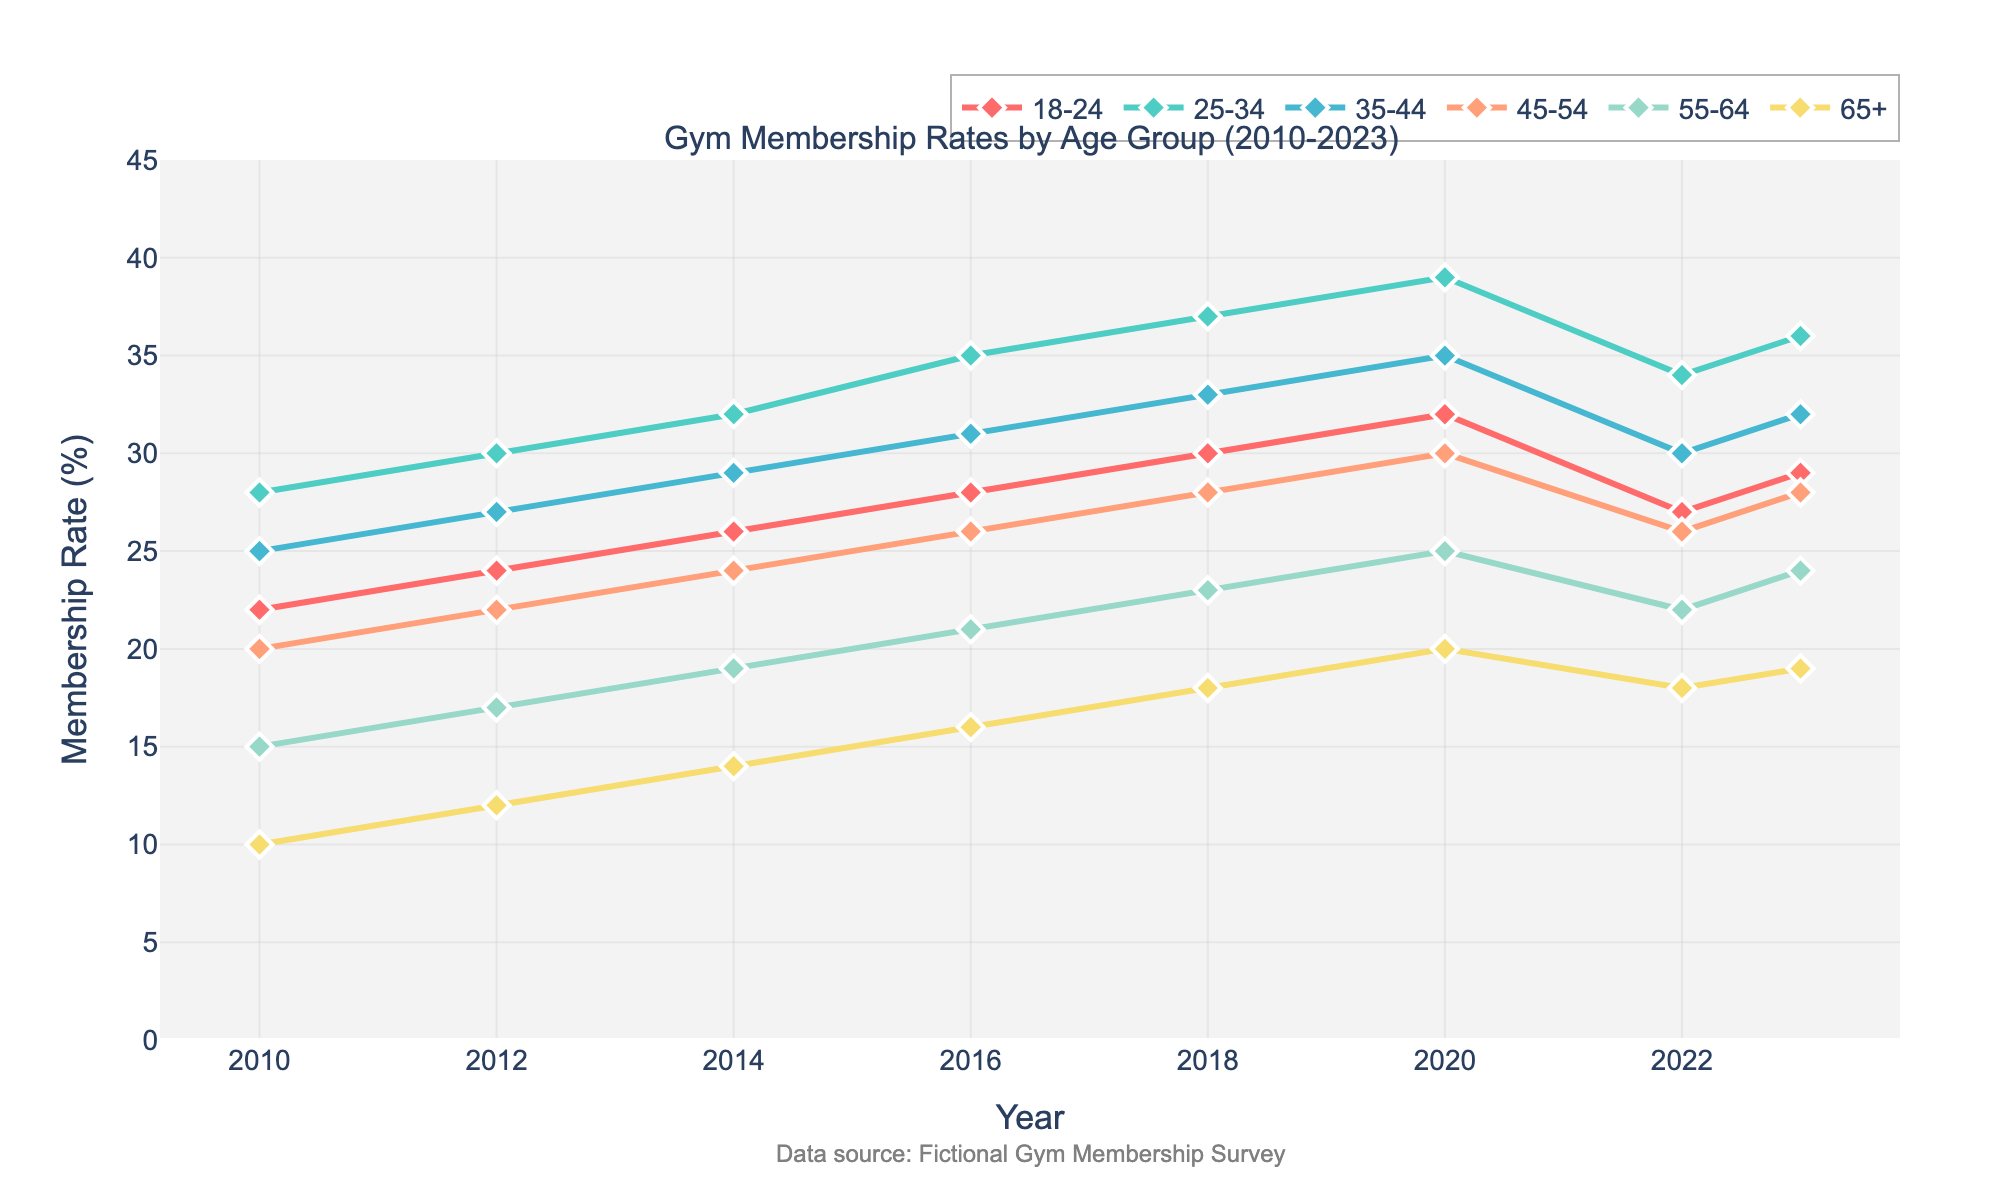What's the trend in gym membership rates for the 18-24 age group from 2010 to 2023? The membership rate for the 18-24 age group rose steadily from 22% in 2010 to 32% in 2020. There was a dip to 27% in 2022, followed by a slight rise to 29% in 2023.
Answer: The trend shows an overall increase with a slight dip in recent years In which year did the 25-34 age group see the highest gym membership rate? By observing the peaks in the line for the 25-34 age group, the highest membership rate is observed in 2020 at 39%.
Answer: 2020 How does the membership rate for the 35-44 age group in 2020 compare to that in 2018? The rate in 2020 is 35%, while in 2018 it is 33%. The rate in 2020 is 2% higher than in 2018.
Answer: 2% higher Which age group had the lowest gym membership rate in 2010, and what was the rate? The lowest membership rate in 2010 was for the 65+ age group at 10%.
Answer: 65+, 10% Compare the change in membership rates for the 45-54 and 55-64 age groups from 2010 to 2023. For the 45-54 age group, the rate increased from 20% to 28%. For the 55-64 age group, it increased from 15% to 24%. The increase for 45-54 is 8%, and for 55-64 it is 9%.
Answer: 45-54: 8%, 55-64: 9% What is the average membership rate for the age group 25-34 over the entire period? The rates are 28%, 30%, 32%, 35%, 37%, 39%, 34%, and 36%. The average is calculated as (28+30+32+35+37+39+34+36)/8 = 33.875%.
Answer: 33.88% Which age group showed a similar membership trend to the 55-64 age group? The 45-54 age group shows a similar increasing trend over the years, but also a slight drop around 2022.
Answer: 45-54 What was the overall increase in the 65+ age group's membership rate from 2010 to 2023? The membership rate for the 65+ age group increased from 10% in 2010 to 19% in 2023, an overall increase of 9%.
Answer: 9% How did the membership rates for the 25-34 and 35-44 age group differ in 2023? In 2023, the memberships rates are 36% for the 25-34 age group and 32% for the 35-44 age group. There is a 4% difference, with the 25-34 age group being higher.
Answer: 4% Which age group experienced a dip in their gym membership rates between 2020 and 2022? The 18-24 age group experienced a dip, dropping from 32% in 2020 to 27% in 2022 before rising to 29% in 2023.
Answer: 18-24 